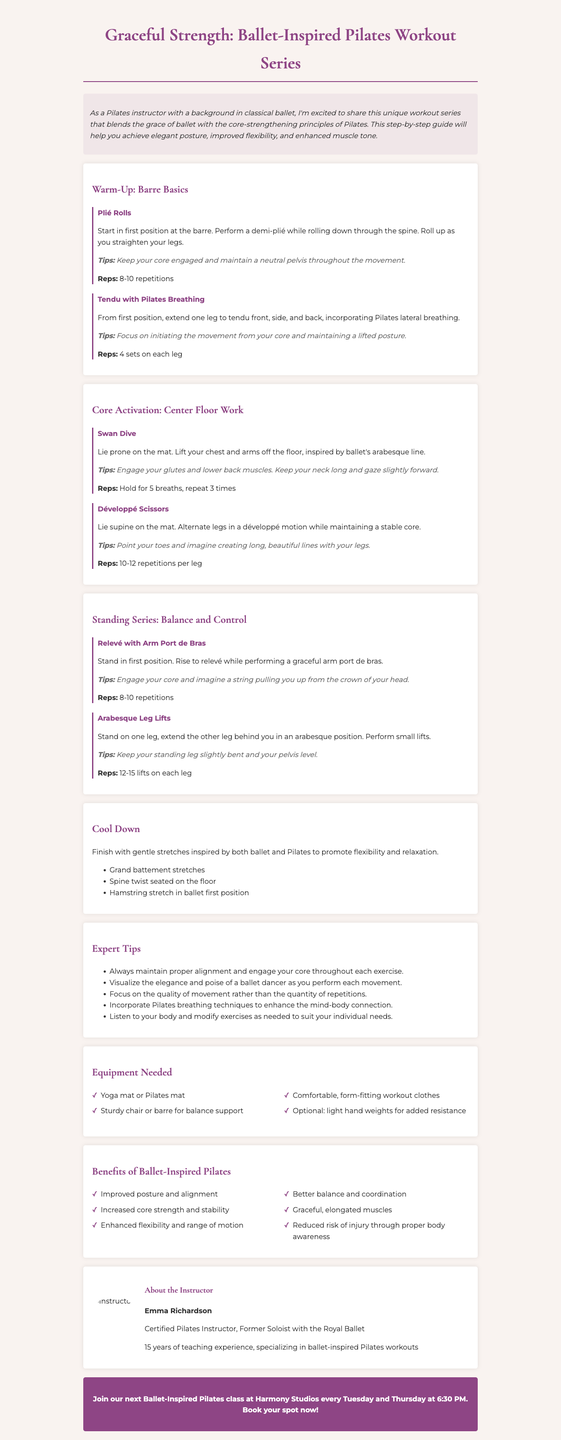What is the title of the newsletter? The title is mentioned at the top of the document.
Answer: Graceful Strength: Ballet-Inspired Pilates Workout Series Who is the instructor? The instructor's name is provided in the about section.
Answer: Emma Richardson How many repetitions are suggested for Plié Rolls? The repetitions for this exercise are listed directly in the document.
Answer: 8-10 repetitions What is the main benefit of the workout series? The benefits are listed in a dedicated section of the document.
Answer: Improved posture and alignment What equipment is needed for the workouts? The equipment list specifies necessary items for the exercises.
Answer: Yoga mat or Pilates mat In which position do you start for the Tendu exercise? The starting position is mentioned in the exercise description.
Answer: First position How many sets are recommended for Tendu with Pilates Breathing? The document specifies the number of sets in the exercise description.
Answer: 4 sets on each leg What type of breathing technique is emphasized in the workout? The document mentions a specific technique related to the exercise.
Answer: Pilates lateral breathing What day and time does the Ballet-Inspired Pilates class take place? The class schedule is given in the call to action section.
Answer: Every Tuesday and Thursday at 6:30 PM 